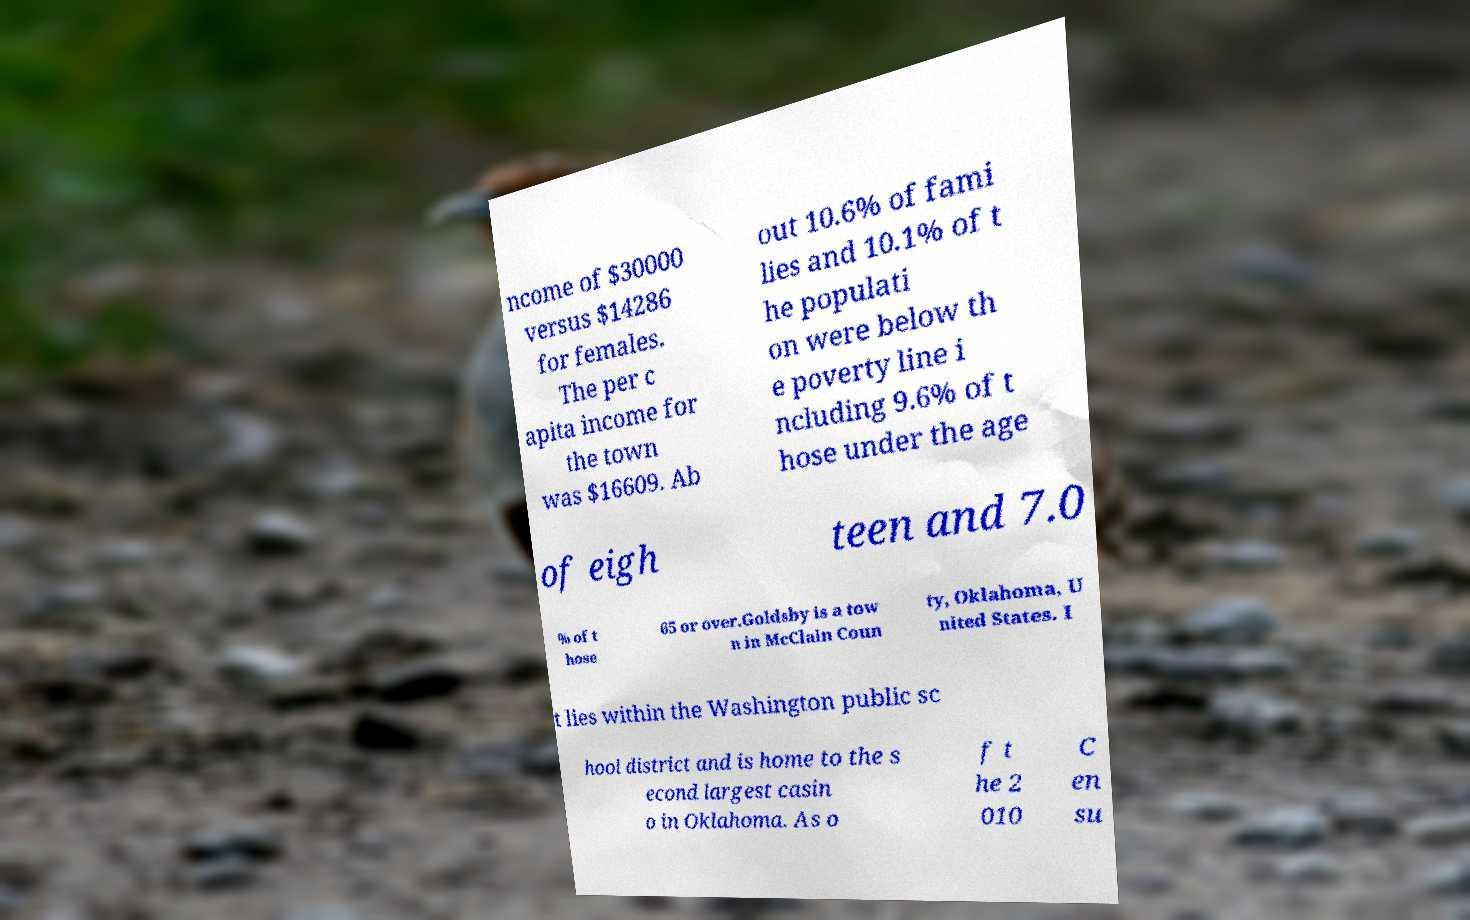For documentation purposes, I need the text within this image transcribed. Could you provide that? ncome of $30000 versus $14286 for females. The per c apita income for the town was $16609. Ab out 10.6% of fami lies and 10.1% of t he populati on were below th e poverty line i ncluding 9.6% of t hose under the age of eigh teen and 7.0 % of t hose 65 or over.Goldsby is a tow n in McClain Coun ty, Oklahoma, U nited States. I t lies within the Washington public sc hool district and is home to the s econd largest casin o in Oklahoma. As o f t he 2 010 C en su 